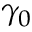<formula> <loc_0><loc_0><loc_500><loc_500>\gamma _ { 0 }</formula> 